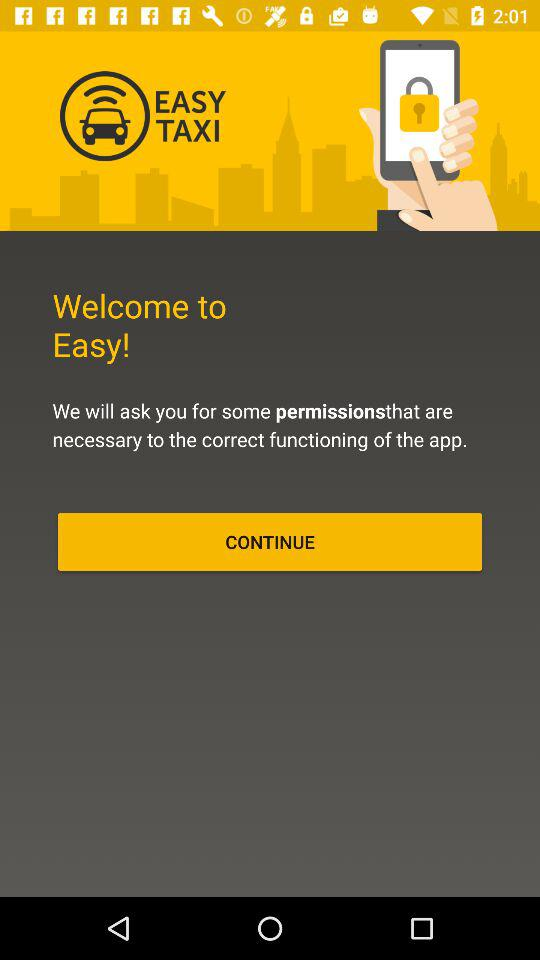What's the application name? The application name is "EASY TAXI". 